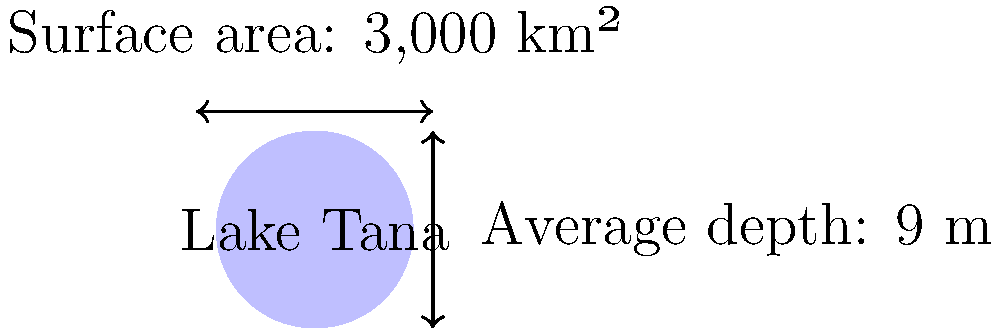Lake Tana, the largest lake in Ethiopia, is crucial for the country's freshwater ecosystem. Given that Lake Tana has a surface area of 3,000 km² and an average depth of 9 meters, estimate its water volume in cubic kilometers (km³). Round your answer to the nearest whole number. To estimate the water volume of Lake Tana, we need to follow these steps:

1. Understand the given information:
   - Surface area (A) = 3,000 km²
   - Average depth (d) = 9 m

2. Convert the average depth from meters to kilometers:
   $9 \text{ m} = 0.009 \text{ km}$

3. Use the formula for volume of a cuboid (length × width × height):
   $V = A \times d$

4. Substitute the values:
   $V = 3,000 \text{ km}² \times 0.009 \text{ km}$

5. Calculate:
   $V = 27 \text{ km}³$

6. Round to the nearest whole number:
   $V \approx 27 \text{ km}³$

Therefore, the estimated water volume of Lake Tana is approximately 27 km³.
Answer: 27 km³ 